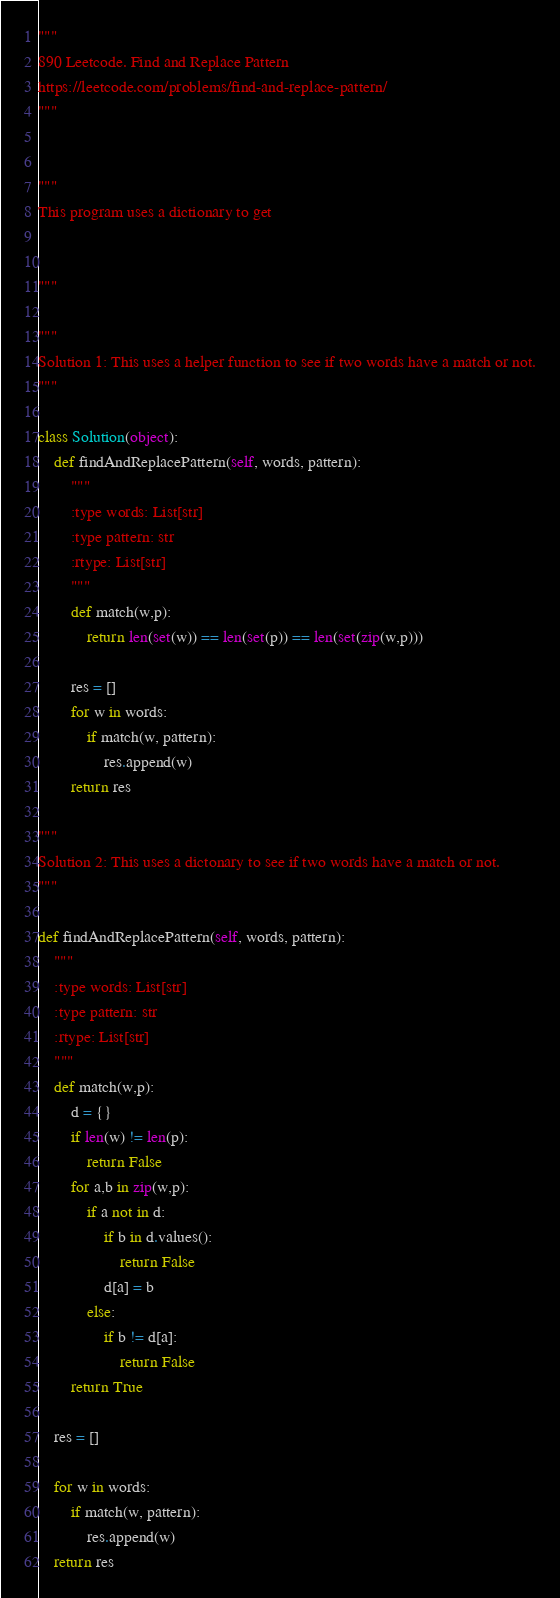<code> <loc_0><loc_0><loc_500><loc_500><_Python_>"""
890 Leetcode. Find and Replace Pattern
https://leetcode.com/problems/find-and-replace-pattern/
"""


"""
This program uses a dictionary to get 


"""

"""
Solution 1: This uses a helper function to see if two words have a match or not.
"""

class Solution(object):
    def findAndReplacePattern(self, words, pattern):
        """
        :type words: List[str]
        :type pattern: str
        :rtype: List[str]
        """
        def match(w,p):
            return len(set(w)) == len(set(p)) == len(set(zip(w,p)))
        
        res = []
        for w in words:
            if match(w, pattern):
                res.append(w)
        return res

"""
Solution 2: This uses a dictonary to see if two words have a match or not.
"""

def findAndReplacePattern(self, words, pattern):
    """
    :type words: List[str]
    :type pattern: str
    :rtype: List[str]
    """
    def match(w,p):
        d = {}
        if len(w) != len(p):
            return False
        for a,b in zip(w,p):
            if a not in d:
                if b in d.values():
                    return False
                d[a] = b
            else:
                if b != d[a]:
                    return False
        return True

    res = []

    for w in words:
        if match(w, pattern):
            res.append(w)
    return res</code> 